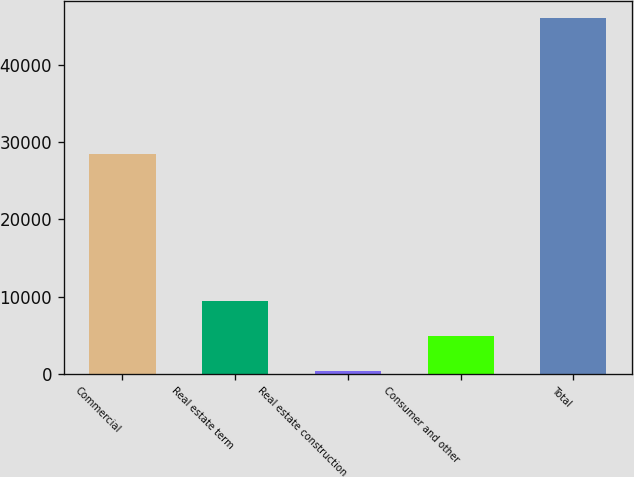Convert chart. <chart><loc_0><loc_0><loc_500><loc_500><bar_chart><fcel>Commercial<fcel>Real estate term<fcel>Real estate construction<fcel>Consumer and other<fcel>Total<nl><fcel>28417<fcel>9499.2<fcel>374<fcel>4936.6<fcel>46000<nl></chart> 